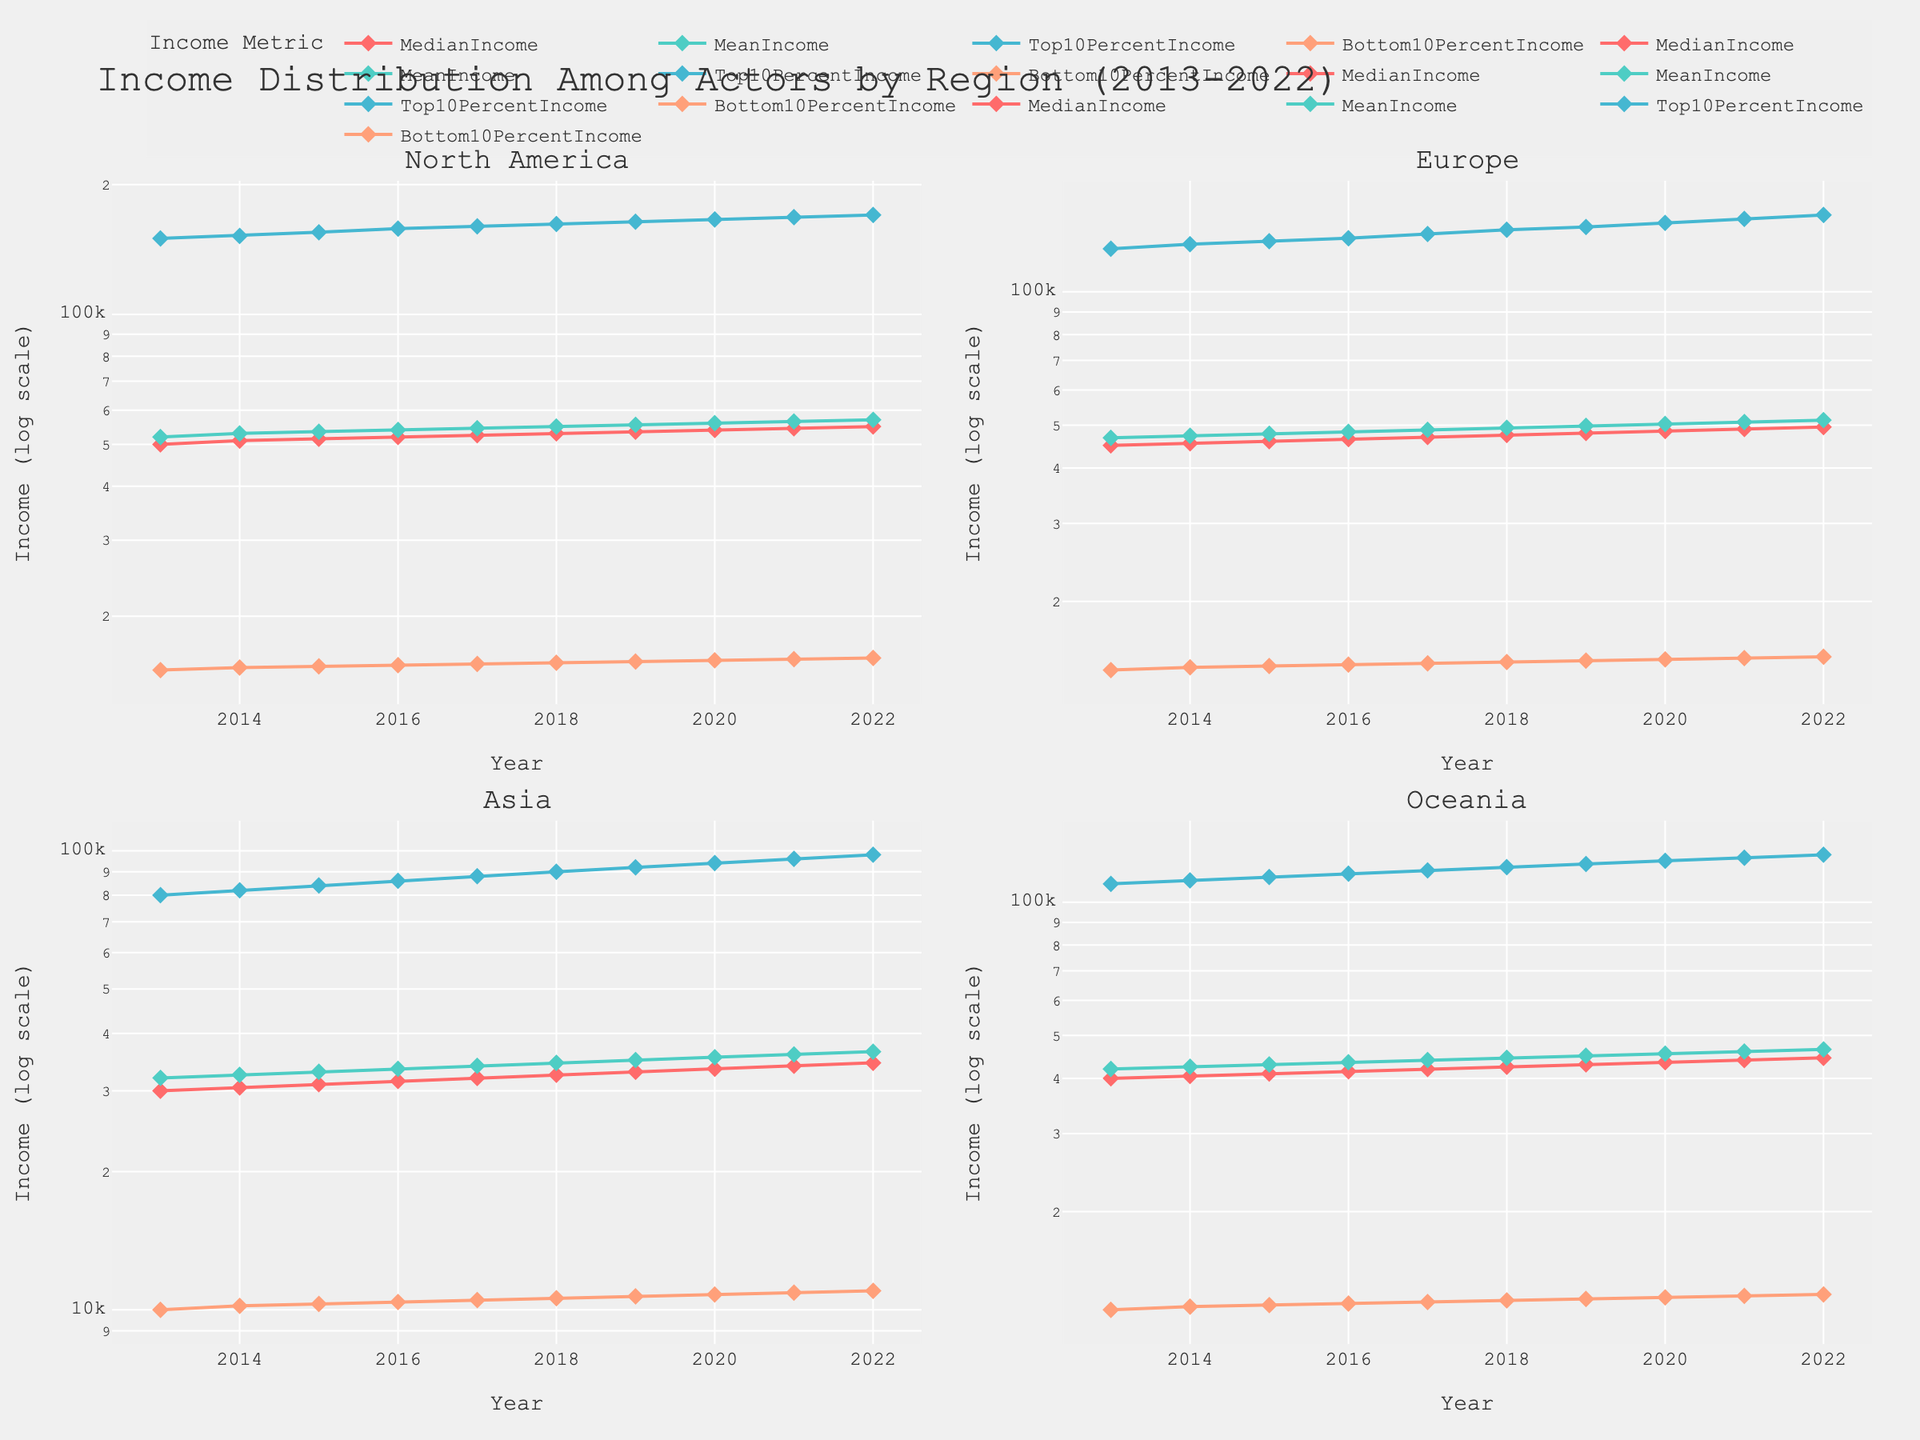What region has the highest top 10% income within the dataset? To determine which region has the highest top 10% income, look at the subplot representing the 'Top 10 Percent Income' line for each region. The North America subplot shows that the income for the top 10% in 2022 is $170,000, which is higher than the other regions.
Answer: North America Which region showed the most significant growth in median income from 2013 to 2022? Calculate the difference between the median incomes of 2022 and 2013 for each region. North America increased from $50,000 to $55,000; Europe from $45,000 to $49,500; Asia from $30,000 to $34,500; and Oceania from $40,000 to $44,500. The largest difference is in North America, which grew by $5,000.
Answer: North America What was the bottom 10% income for Asia in 2018? Look at the subplot for Asia and find the point on the 'Bottom 10 Percent Income' line for the year 2018. The value is $10,600.
Answer: $10,600 Does the mean income consistently increase for all regions over the years? Check the 'Mean Income' line in each region’s subplot. Observe the trend from 2013 to 2022. All lines show a generally upward trend, indicating consistent growth in mean income across all regions.
Answer: Yes Which two regions have the closest top 10% income in 2022, and what are their values? Refer to the 'Top 10 Percent Income' lines on the respective subplots. The 2022 values for Europe and Oceania are $149,000 and $128,000, respectively. These are the closest compared to other regions.
Answer: Europe: $149,000, Oceania: $128,000 By how much did the median income increase in Europe from 2016 to 2022? Locate the 2016 and 2022 points on the 'Median Income' line for Europe. The values are $46,500 and $49,500. The increase is $49,500 - $46,500 = $3,000.
Answer: $3,000 In North America, what income year shows the steepest rise in mean income? Identify the 'Mean Income' line in the North America subplot. Visually inspect for the year where the line has the steepest slope. The line appears steepest between 2013 and 2014, rising from $52,000 to $53,000. This is a rise of $1,000.
Answer: 2013-2014 Which region has the lowest bottom 10% income in the last year of the dataset? Compare the 'Bottom 10 Percent Income' lines for all regions in the year 2022. Asia has the lowest value at $11,000.
Answer: Asia 